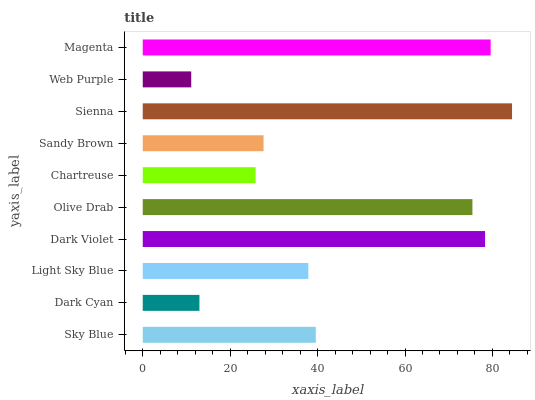Is Web Purple the minimum?
Answer yes or no. Yes. Is Sienna the maximum?
Answer yes or no. Yes. Is Dark Cyan the minimum?
Answer yes or no. No. Is Dark Cyan the maximum?
Answer yes or no. No. Is Sky Blue greater than Dark Cyan?
Answer yes or no. Yes. Is Dark Cyan less than Sky Blue?
Answer yes or no. Yes. Is Dark Cyan greater than Sky Blue?
Answer yes or no. No. Is Sky Blue less than Dark Cyan?
Answer yes or no. No. Is Sky Blue the high median?
Answer yes or no. Yes. Is Light Sky Blue the low median?
Answer yes or no. Yes. Is Dark Violet the high median?
Answer yes or no. No. Is Sky Blue the low median?
Answer yes or no. No. 